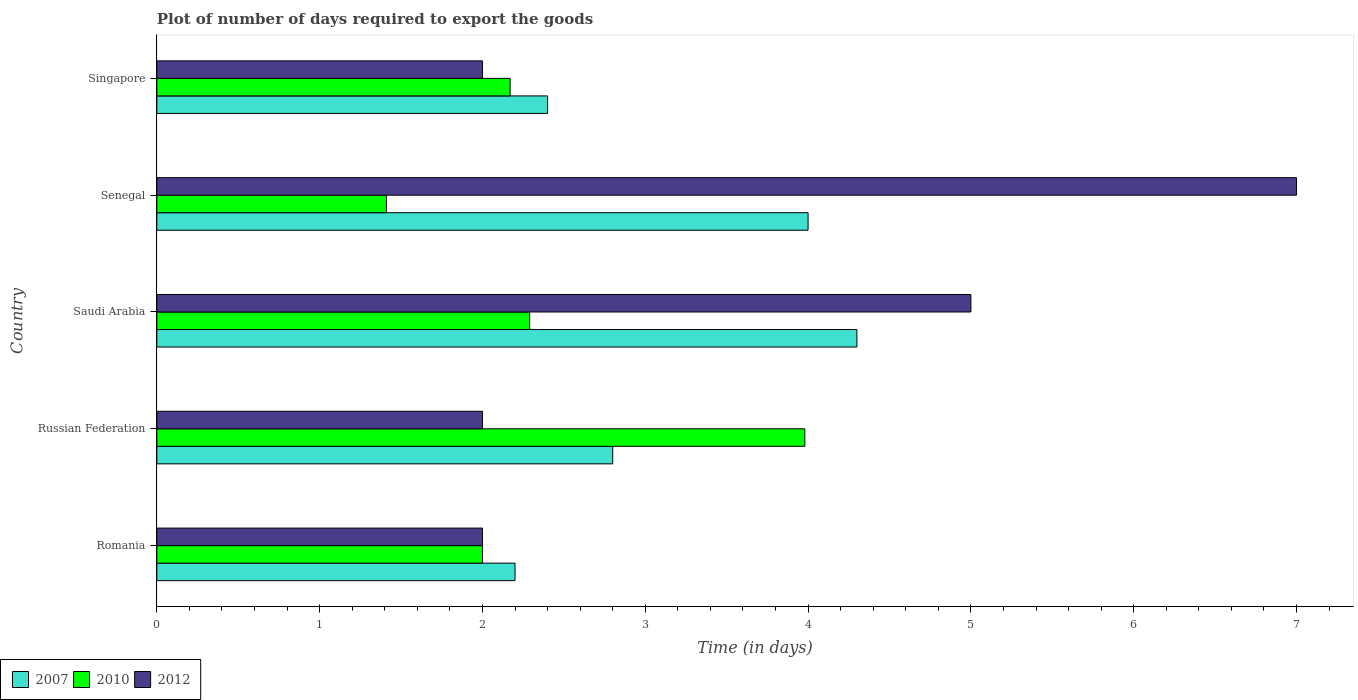Are the number of bars per tick equal to the number of legend labels?
Keep it short and to the point. Yes. How many bars are there on the 4th tick from the bottom?
Offer a very short reply. 3. What is the label of the 3rd group of bars from the top?
Your response must be concise. Saudi Arabia. In how many cases, is the number of bars for a given country not equal to the number of legend labels?
Provide a succinct answer. 0. What is the time required to export goods in 2012 in Saudi Arabia?
Ensure brevity in your answer.  5. Across all countries, what is the maximum time required to export goods in 2010?
Make the answer very short. 3.98. Across all countries, what is the minimum time required to export goods in 2007?
Offer a terse response. 2.2. In which country was the time required to export goods in 2010 maximum?
Make the answer very short. Russian Federation. In which country was the time required to export goods in 2007 minimum?
Your answer should be compact. Romania. What is the total time required to export goods in 2007 in the graph?
Provide a succinct answer. 15.7. What is the difference between the time required to export goods in 2010 in Senegal and that in Singapore?
Provide a short and direct response. -0.76. What is the average time required to export goods in 2010 per country?
Offer a terse response. 2.37. What is the difference between the time required to export goods in 2007 and time required to export goods in 2010 in Senegal?
Keep it short and to the point. 2.59. What is the ratio of the time required to export goods in 2010 in Russian Federation to that in Senegal?
Make the answer very short. 2.82. Is the time required to export goods in 2012 in Saudi Arabia less than that in Senegal?
Your answer should be compact. Yes. What is the difference between the highest and the second highest time required to export goods in 2010?
Your answer should be very brief. 1.69. What is the difference between the highest and the lowest time required to export goods in 2010?
Provide a succinct answer. 2.57. In how many countries, is the time required to export goods in 2007 greater than the average time required to export goods in 2007 taken over all countries?
Provide a short and direct response. 2. Is the sum of the time required to export goods in 2010 in Romania and Senegal greater than the maximum time required to export goods in 2007 across all countries?
Your answer should be compact. No. What does the 3rd bar from the bottom in Singapore represents?
Provide a short and direct response. 2012. What is the title of the graph?
Your answer should be very brief. Plot of number of days required to export the goods. Does "2013" appear as one of the legend labels in the graph?
Ensure brevity in your answer.  No. What is the label or title of the X-axis?
Keep it short and to the point. Time (in days). What is the Time (in days) of 2007 in Romania?
Give a very brief answer. 2.2. What is the Time (in days) in 2010 in Romania?
Offer a very short reply. 2. What is the Time (in days) in 2012 in Romania?
Your response must be concise. 2. What is the Time (in days) of 2010 in Russian Federation?
Provide a short and direct response. 3.98. What is the Time (in days) of 2007 in Saudi Arabia?
Offer a terse response. 4.3. What is the Time (in days) in 2010 in Saudi Arabia?
Make the answer very short. 2.29. What is the Time (in days) in 2012 in Saudi Arabia?
Your response must be concise. 5. What is the Time (in days) in 2007 in Senegal?
Ensure brevity in your answer.  4. What is the Time (in days) of 2010 in Senegal?
Offer a very short reply. 1.41. What is the Time (in days) of 2010 in Singapore?
Ensure brevity in your answer.  2.17. What is the Time (in days) in 2012 in Singapore?
Offer a terse response. 2. Across all countries, what is the maximum Time (in days) in 2007?
Offer a terse response. 4.3. Across all countries, what is the maximum Time (in days) of 2010?
Provide a short and direct response. 3.98. Across all countries, what is the minimum Time (in days) of 2007?
Offer a very short reply. 2.2. Across all countries, what is the minimum Time (in days) in 2010?
Your response must be concise. 1.41. What is the total Time (in days) of 2010 in the graph?
Provide a short and direct response. 11.85. What is the total Time (in days) of 2012 in the graph?
Your answer should be very brief. 18. What is the difference between the Time (in days) in 2010 in Romania and that in Russian Federation?
Provide a succinct answer. -1.98. What is the difference between the Time (in days) of 2012 in Romania and that in Russian Federation?
Offer a terse response. 0. What is the difference between the Time (in days) of 2010 in Romania and that in Saudi Arabia?
Your response must be concise. -0.29. What is the difference between the Time (in days) of 2012 in Romania and that in Saudi Arabia?
Offer a terse response. -3. What is the difference between the Time (in days) in 2007 in Romania and that in Senegal?
Make the answer very short. -1.8. What is the difference between the Time (in days) of 2010 in Romania and that in Senegal?
Offer a terse response. 0.59. What is the difference between the Time (in days) of 2007 in Romania and that in Singapore?
Keep it short and to the point. -0.2. What is the difference between the Time (in days) in 2010 in Romania and that in Singapore?
Give a very brief answer. -0.17. What is the difference between the Time (in days) of 2012 in Romania and that in Singapore?
Ensure brevity in your answer.  0. What is the difference between the Time (in days) of 2010 in Russian Federation and that in Saudi Arabia?
Make the answer very short. 1.69. What is the difference between the Time (in days) in 2012 in Russian Federation and that in Saudi Arabia?
Your answer should be very brief. -3. What is the difference between the Time (in days) in 2007 in Russian Federation and that in Senegal?
Make the answer very short. -1.2. What is the difference between the Time (in days) in 2010 in Russian Federation and that in Senegal?
Your response must be concise. 2.57. What is the difference between the Time (in days) in 2007 in Russian Federation and that in Singapore?
Ensure brevity in your answer.  0.4. What is the difference between the Time (in days) of 2010 in Russian Federation and that in Singapore?
Keep it short and to the point. 1.81. What is the difference between the Time (in days) of 2012 in Russian Federation and that in Singapore?
Give a very brief answer. 0. What is the difference between the Time (in days) in 2007 in Saudi Arabia and that in Senegal?
Your answer should be very brief. 0.3. What is the difference between the Time (in days) in 2010 in Saudi Arabia and that in Singapore?
Make the answer very short. 0.12. What is the difference between the Time (in days) of 2007 in Senegal and that in Singapore?
Ensure brevity in your answer.  1.6. What is the difference between the Time (in days) of 2010 in Senegal and that in Singapore?
Your response must be concise. -0.76. What is the difference between the Time (in days) in 2007 in Romania and the Time (in days) in 2010 in Russian Federation?
Offer a very short reply. -1.78. What is the difference between the Time (in days) of 2010 in Romania and the Time (in days) of 2012 in Russian Federation?
Keep it short and to the point. 0. What is the difference between the Time (in days) of 2007 in Romania and the Time (in days) of 2010 in Saudi Arabia?
Provide a succinct answer. -0.09. What is the difference between the Time (in days) of 2007 in Romania and the Time (in days) of 2010 in Senegal?
Your answer should be compact. 0.79. What is the difference between the Time (in days) in 2010 in Romania and the Time (in days) in 2012 in Senegal?
Make the answer very short. -5. What is the difference between the Time (in days) of 2007 in Romania and the Time (in days) of 2010 in Singapore?
Offer a very short reply. 0.03. What is the difference between the Time (in days) of 2007 in Russian Federation and the Time (in days) of 2010 in Saudi Arabia?
Make the answer very short. 0.51. What is the difference between the Time (in days) in 2007 in Russian Federation and the Time (in days) in 2012 in Saudi Arabia?
Your answer should be very brief. -2.2. What is the difference between the Time (in days) of 2010 in Russian Federation and the Time (in days) of 2012 in Saudi Arabia?
Offer a very short reply. -1.02. What is the difference between the Time (in days) of 2007 in Russian Federation and the Time (in days) of 2010 in Senegal?
Make the answer very short. 1.39. What is the difference between the Time (in days) in 2007 in Russian Federation and the Time (in days) in 2012 in Senegal?
Your answer should be compact. -4.2. What is the difference between the Time (in days) of 2010 in Russian Federation and the Time (in days) of 2012 in Senegal?
Provide a succinct answer. -3.02. What is the difference between the Time (in days) in 2007 in Russian Federation and the Time (in days) in 2010 in Singapore?
Your answer should be very brief. 0.63. What is the difference between the Time (in days) in 2010 in Russian Federation and the Time (in days) in 2012 in Singapore?
Give a very brief answer. 1.98. What is the difference between the Time (in days) of 2007 in Saudi Arabia and the Time (in days) of 2010 in Senegal?
Your answer should be compact. 2.89. What is the difference between the Time (in days) in 2010 in Saudi Arabia and the Time (in days) in 2012 in Senegal?
Provide a succinct answer. -4.71. What is the difference between the Time (in days) of 2007 in Saudi Arabia and the Time (in days) of 2010 in Singapore?
Your response must be concise. 2.13. What is the difference between the Time (in days) in 2010 in Saudi Arabia and the Time (in days) in 2012 in Singapore?
Provide a short and direct response. 0.29. What is the difference between the Time (in days) of 2007 in Senegal and the Time (in days) of 2010 in Singapore?
Give a very brief answer. 1.83. What is the difference between the Time (in days) in 2007 in Senegal and the Time (in days) in 2012 in Singapore?
Your response must be concise. 2. What is the difference between the Time (in days) in 2010 in Senegal and the Time (in days) in 2012 in Singapore?
Your response must be concise. -0.59. What is the average Time (in days) of 2007 per country?
Your response must be concise. 3.14. What is the average Time (in days) of 2010 per country?
Offer a very short reply. 2.37. What is the average Time (in days) in 2012 per country?
Provide a succinct answer. 3.6. What is the difference between the Time (in days) in 2007 and Time (in days) in 2012 in Romania?
Ensure brevity in your answer.  0.2. What is the difference between the Time (in days) of 2010 and Time (in days) of 2012 in Romania?
Your answer should be very brief. 0. What is the difference between the Time (in days) of 2007 and Time (in days) of 2010 in Russian Federation?
Provide a short and direct response. -1.18. What is the difference between the Time (in days) of 2010 and Time (in days) of 2012 in Russian Federation?
Provide a short and direct response. 1.98. What is the difference between the Time (in days) in 2007 and Time (in days) in 2010 in Saudi Arabia?
Offer a very short reply. 2.01. What is the difference between the Time (in days) of 2007 and Time (in days) of 2012 in Saudi Arabia?
Your response must be concise. -0.7. What is the difference between the Time (in days) of 2010 and Time (in days) of 2012 in Saudi Arabia?
Ensure brevity in your answer.  -2.71. What is the difference between the Time (in days) in 2007 and Time (in days) in 2010 in Senegal?
Keep it short and to the point. 2.59. What is the difference between the Time (in days) of 2010 and Time (in days) of 2012 in Senegal?
Make the answer very short. -5.59. What is the difference between the Time (in days) in 2007 and Time (in days) in 2010 in Singapore?
Offer a very short reply. 0.23. What is the difference between the Time (in days) in 2010 and Time (in days) in 2012 in Singapore?
Your answer should be compact. 0.17. What is the ratio of the Time (in days) of 2007 in Romania to that in Russian Federation?
Make the answer very short. 0.79. What is the ratio of the Time (in days) in 2010 in Romania to that in Russian Federation?
Make the answer very short. 0.5. What is the ratio of the Time (in days) in 2012 in Romania to that in Russian Federation?
Your answer should be compact. 1. What is the ratio of the Time (in days) of 2007 in Romania to that in Saudi Arabia?
Provide a short and direct response. 0.51. What is the ratio of the Time (in days) of 2010 in Romania to that in Saudi Arabia?
Keep it short and to the point. 0.87. What is the ratio of the Time (in days) in 2012 in Romania to that in Saudi Arabia?
Provide a succinct answer. 0.4. What is the ratio of the Time (in days) of 2007 in Romania to that in Senegal?
Make the answer very short. 0.55. What is the ratio of the Time (in days) of 2010 in Romania to that in Senegal?
Provide a succinct answer. 1.42. What is the ratio of the Time (in days) in 2012 in Romania to that in Senegal?
Ensure brevity in your answer.  0.29. What is the ratio of the Time (in days) of 2007 in Romania to that in Singapore?
Your answer should be very brief. 0.92. What is the ratio of the Time (in days) of 2010 in Romania to that in Singapore?
Keep it short and to the point. 0.92. What is the ratio of the Time (in days) of 2007 in Russian Federation to that in Saudi Arabia?
Provide a short and direct response. 0.65. What is the ratio of the Time (in days) of 2010 in Russian Federation to that in Saudi Arabia?
Your answer should be very brief. 1.74. What is the ratio of the Time (in days) of 2010 in Russian Federation to that in Senegal?
Make the answer very short. 2.82. What is the ratio of the Time (in days) in 2012 in Russian Federation to that in Senegal?
Give a very brief answer. 0.29. What is the ratio of the Time (in days) of 2007 in Russian Federation to that in Singapore?
Give a very brief answer. 1.17. What is the ratio of the Time (in days) of 2010 in Russian Federation to that in Singapore?
Provide a short and direct response. 1.83. What is the ratio of the Time (in days) of 2007 in Saudi Arabia to that in Senegal?
Your response must be concise. 1.07. What is the ratio of the Time (in days) in 2010 in Saudi Arabia to that in Senegal?
Give a very brief answer. 1.62. What is the ratio of the Time (in days) in 2012 in Saudi Arabia to that in Senegal?
Keep it short and to the point. 0.71. What is the ratio of the Time (in days) of 2007 in Saudi Arabia to that in Singapore?
Offer a terse response. 1.79. What is the ratio of the Time (in days) in 2010 in Saudi Arabia to that in Singapore?
Give a very brief answer. 1.06. What is the ratio of the Time (in days) in 2012 in Saudi Arabia to that in Singapore?
Make the answer very short. 2.5. What is the ratio of the Time (in days) of 2007 in Senegal to that in Singapore?
Your answer should be very brief. 1.67. What is the ratio of the Time (in days) of 2010 in Senegal to that in Singapore?
Provide a short and direct response. 0.65. What is the difference between the highest and the second highest Time (in days) of 2010?
Give a very brief answer. 1.69. What is the difference between the highest and the lowest Time (in days) in 2010?
Give a very brief answer. 2.57. 